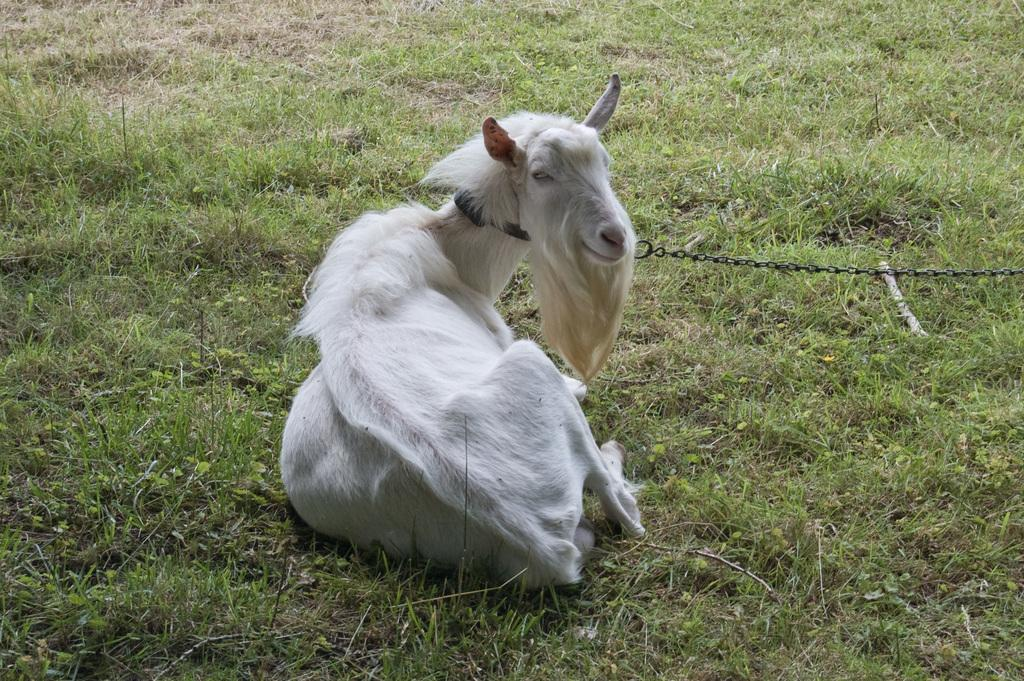Where was the picture taken? The picture was taken outside. What animal can be seen in the image? There is a goat in the image. What is the goat sitting on? The goat is sitting on the grass. Is there any indication of the goat being restrained in the image? Yes, there is a metal chain tied to the neck of the goat. What type of steel structure can be seen in the background of the image? There is no steel structure visible in the background of the image. 